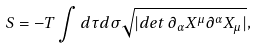Convert formula to latex. <formula><loc_0><loc_0><loc_500><loc_500>S = - T \int d \tau d \sigma \sqrt { | d e t \, \partial _ { \alpha } X ^ { \mu } \partial ^ { \alpha } X _ { \mu } | } ,</formula> 